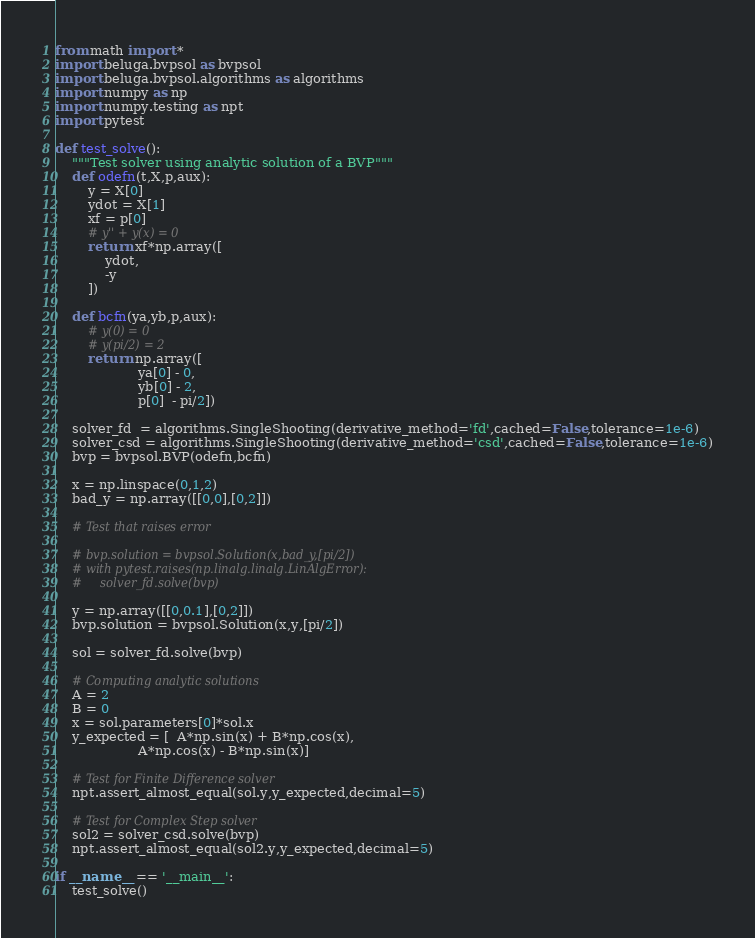Convert code to text. <code><loc_0><loc_0><loc_500><loc_500><_Python_>from math import *
import beluga.bvpsol as bvpsol
import beluga.bvpsol.algorithms as algorithms
import numpy as np
import numpy.testing as npt
import pytest

def test_solve():
    """Test solver using analytic solution of a BVP"""
    def odefn(t,X,p,aux):
        y = X[0]
        ydot = X[1]
        xf = p[0]
        # y'' + y(x) = 0
        return xf*np.array([
            ydot,
            -y
        ])

    def bcfn(ya,yb,p,aux):
        # y(0) = 0
        # y(pi/2) = 2
        return np.array([
                    ya[0] - 0,
                    yb[0] - 2,
                    p[0]  - pi/2])

    solver_fd  = algorithms.SingleShooting(derivative_method='fd',cached=False,tolerance=1e-6)
    solver_csd = algorithms.SingleShooting(derivative_method='csd',cached=False,tolerance=1e-6)
    bvp = bvpsol.BVP(odefn,bcfn)

    x = np.linspace(0,1,2)
    bad_y = np.array([[0,0],[0,2]])

    # Test that raises error

    # bvp.solution = bvpsol.Solution(x,bad_y,[pi/2])
    # with pytest.raises(np.linalg.linalg.LinAlgError):
    #     solver_fd.solve(bvp)

    y = np.array([[0,0.1],[0,2]])
    bvp.solution = bvpsol.Solution(x,y,[pi/2])

    sol = solver_fd.solve(bvp)

    # Computing analytic solutions
    A = 2
    B = 0
    x = sol.parameters[0]*sol.x
    y_expected = [  A*np.sin(x) + B*np.cos(x),
                    A*np.cos(x) - B*np.sin(x)]

    # Test for Finite Difference solver
    npt.assert_almost_equal(sol.y,y_expected,decimal=5)

    # Test for Complex Step solver
    sol2 = solver_csd.solve(bvp)
    npt.assert_almost_equal(sol2.y,y_expected,decimal=5)

if __name__ == '__main__':
    test_solve()
</code> 